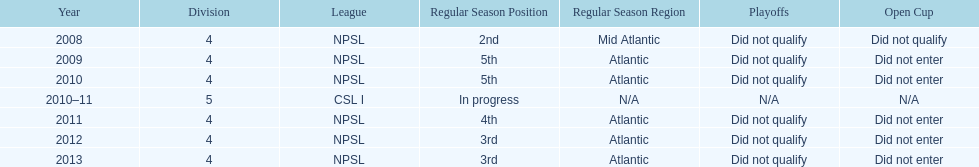What was the last year they came in 3rd place 2013. 